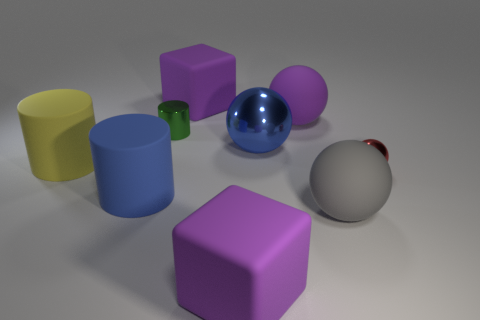Is there any other thing that is made of the same material as the small green cylinder?
Offer a very short reply. Yes. What number of shiny objects are either small red objects or purple things?
Keep it short and to the point. 1. What material is the thing that is the same size as the red sphere?
Provide a succinct answer. Metal. Is there a tiny green thing that has the same material as the gray object?
Provide a short and direct response. No. There is a large blue thing that is in front of the matte cylinder behind the blue object in front of the yellow cylinder; what shape is it?
Provide a short and direct response. Cylinder. Is the size of the yellow cylinder the same as the purple rubber object in front of the purple ball?
Your answer should be very brief. Yes. There is a large thing that is in front of the big shiny thing and behind the blue cylinder; what is its shape?
Your answer should be compact. Cylinder. What number of large things are green shiny cylinders or purple cubes?
Your answer should be very brief. 2. Is the number of small things in front of the tiny metallic ball the same as the number of purple cubes that are in front of the yellow thing?
Keep it short and to the point. No. How many other objects are the same color as the tiny cylinder?
Make the answer very short. 0. 